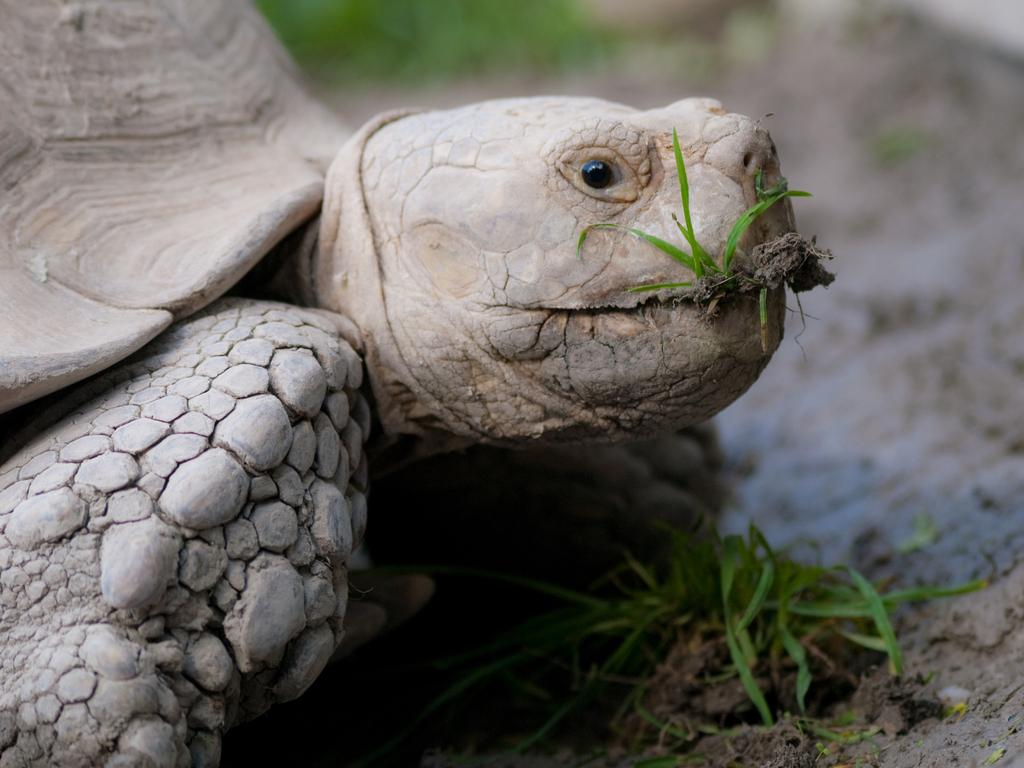What animal can be seen in the image? There is a tortoise in the image. What type of vegetation is present in the image? There is grass in the image. Can you describe the background of the image? The background of the image is blurred. What type of glove is the tortoise wearing in the image? There is no glove present in the image, as tortoises do not wear gloves. 